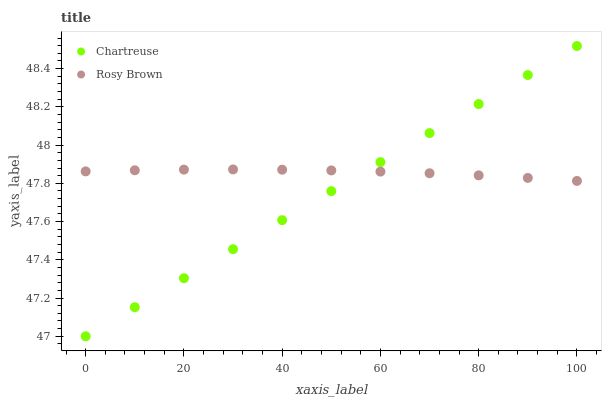Does Chartreuse have the minimum area under the curve?
Answer yes or no. Yes. Does Rosy Brown have the maximum area under the curve?
Answer yes or no. Yes. Does Rosy Brown have the minimum area under the curve?
Answer yes or no. No. Is Chartreuse the smoothest?
Answer yes or no. Yes. Is Rosy Brown the roughest?
Answer yes or no. Yes. Is Rosy Brown the smoothest?
Answer yes or no. No. Does Chartreuse have the lowest value?
Answer yes or no. Yes. Does Rosy Brown have the lowest value?
Answer yes or no. No. Does Chartreuse have the highest value?
Answer yes or no. Yes. Does Rosy Brown have the highest value?
Answer yes or no. No. Does Chartreuse intersect Rosy Brown?
Answer yes or no. Yes. Is Chartreuse less than Rosy Brown?
Answer yes or no. No. Is Chartreuse greater than Rosy Brown?
Answer yes or no. No. 